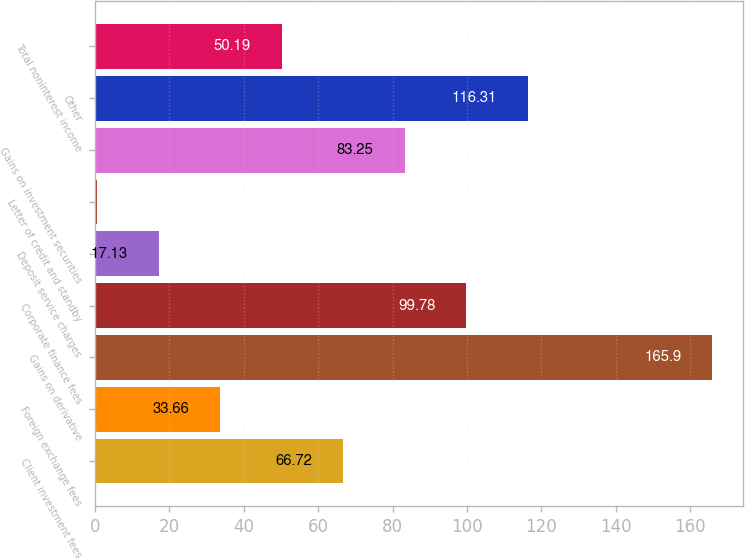<chart> <loc_0><loc_0><loc_500><loc_500><bar_chart><fcel>Client investment fees<fcel>Foreign exchange fees<fcel>Gains on derivative<fcel>Corporate finance fees<fcel>Deposit service charges<fcel>Letter of credit and standby<fcel>Gains on investment securities<fcel>Other<fcel>Total noninterest income<nl><fcel>66.72<fcel>33.66<fcel>165.9<fcel>99.78<fcel>17.13<fcel>0.6<fcel>83.25<fcel>116.31<fcel>50.19<nl></chart> 